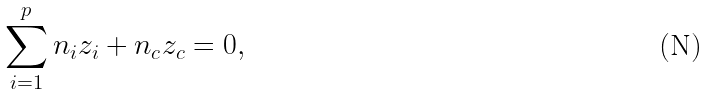Convert formula to latex. <formula><loc_0><loc_0><loc_500><loc_500>\sum _ { i = 1 } ^ { p } n _ { i } z _ { i } + n _ { c } z _ { c } = 0 ,</formula> 